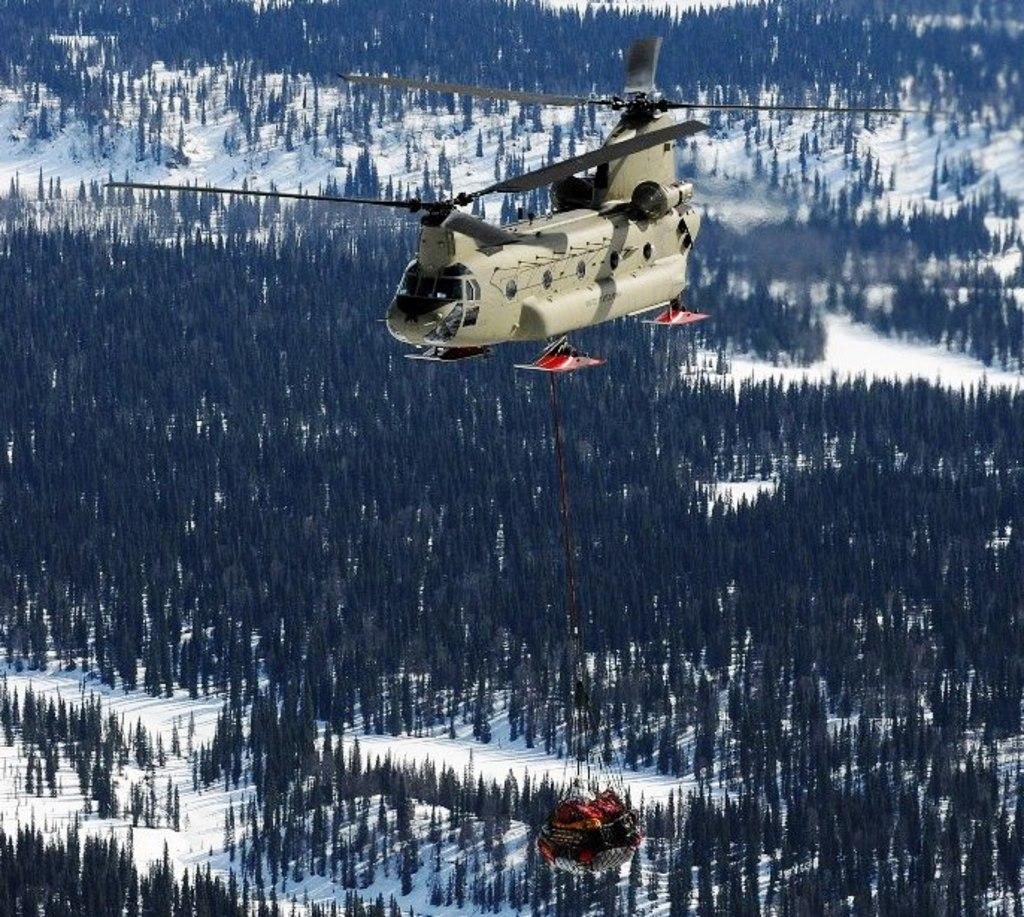What is flying in the sky in the image? There is a helicopter flying in the sky in the image. What can be seen hanging in the image? There is an object hanging in the image. What type of vegetation is visible in the background of the image? There are trees in the background of the image. What is the condition of the ground in the image? There is snow on the ground. What type of metal is used to construct the steps in the image? There are no steps present in the image, so it is not possible to determine the type of metal used for their construction. 